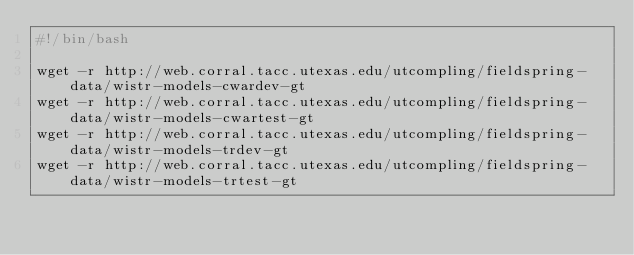<code> <loc_0><loc_0><loc_500><loc_500><_Bash_>#!/bin/bash

wget -r http://web.corral.tacc.utexas.edu/utcompling/fieldspring-data/wistr-models-cwardev-gt
wget -r http://web.corral.tacc.utexas.edu/utcompling/fieldspring-data/wistr-models-cwartest-gt
wget -r http://web.corral.tacc.utexas.edu/utcompling/fieldspring-data/wistr-models-trdev-gt
wget -r http://web.corral.tacc.utexas.edu/utcompling/fieldspring-data/wistr-models-trtest-gt</code> 